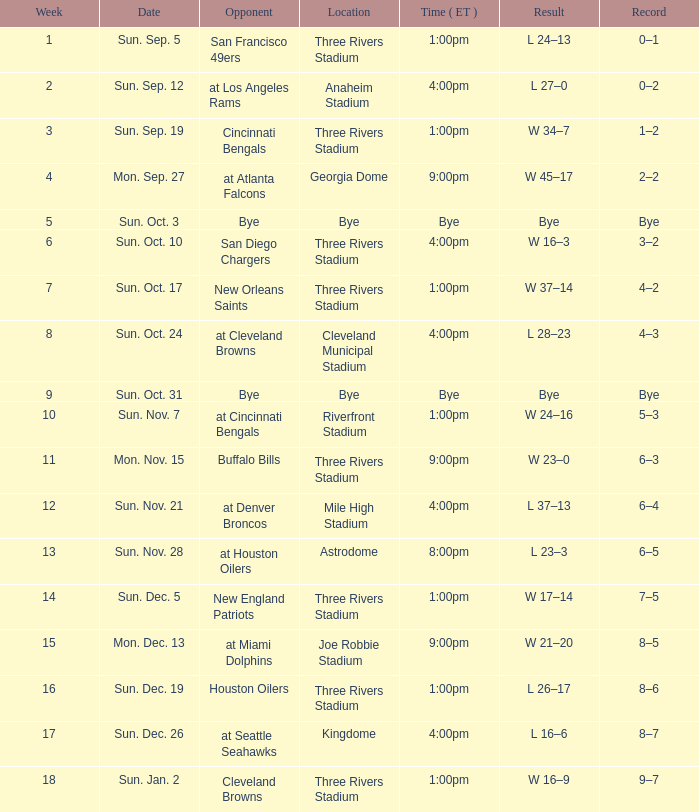What is the record of the game that has a result of w 45–17? 2–2. 